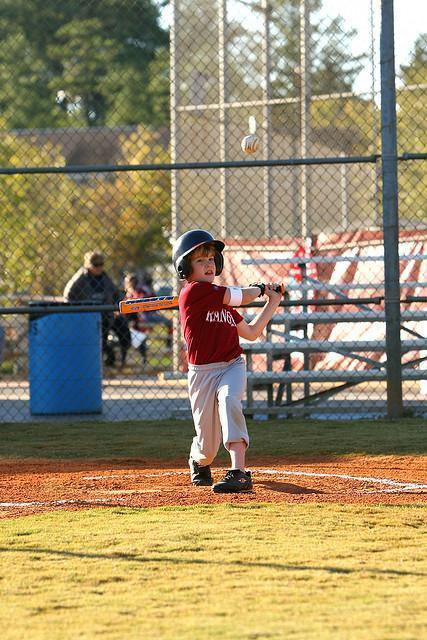How many people are there?
Give a very brief answer. 2. 